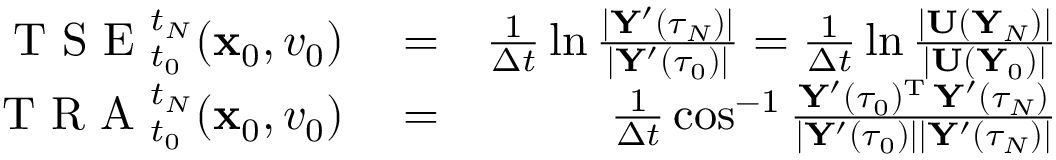<formula> <loc_0><loc_0><loc_500><loc_500>\begin{array} { r l r } { T S E _ { t _ { 0 } } ^ { t _ { N } } ( { \mathbf x } _ { 0 } , v _ { 0 } ) } & = } & { \frac { 1 } { \Delta t } \ln \frac { | { \mathbf Y } ^ { \prime } ( \tau _ { N } ) | } { | { \mathbf Y } ^ { \prime } ( \tau _ { 0 } ) | } = \frac { 1 } { \Delta t } \ln \frac { | { \mathbf U } ( { \mathbf Y } _ { N } ) | } { | { \mathbf U } ( { \mathbf Y } _ { 0 } ) | } } \\ { T R A _ { t _ { 0 } } ^ { t _ { N } } ( { \mathbf x } _ { 0 } , v _ { 0 } ) } & = } & { \frac { 1 } { \Delta t } \cos ^ { - 1 } \frac { { \mathbf Y } ^ { \prime } ( \tau _ { 0 } ) ^ { \mathrm T } \, { \mathbf Y } ^ { \prime } ( \tau _ { N } ) } { | { \mathbf Y } ^ { \prime } ( \tau _ { 0 } ) | | { \mathbf Y } ^ { \prime } ( \tau _ { N } ) | } } \end{array}</formula> 